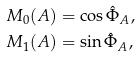<formula> <loc_0><loc_0><loc_500><loc_500>M _ { 0 } ( A ) & = \cos \hat { \Phi } _ { A } , \\ M _ { 1 } ( A ) & = \sin \hat { \Phi } _ { A } ,</formula> 